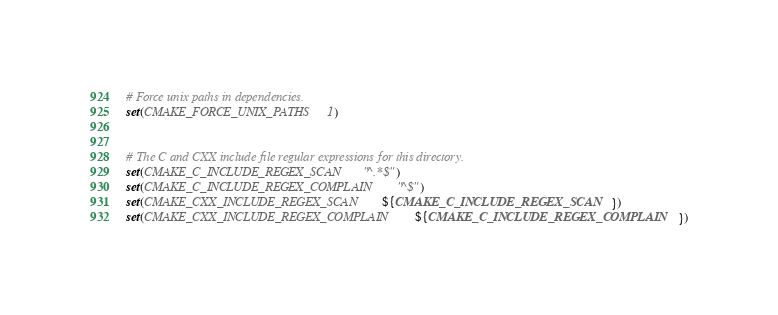Convert code to text. <code><loc_0><loc_0><loc_500><loc_500><_CMake_>
# Force unix paths in dependencies.
set(CMAKE_FORCE_UNIX_PATHS 1)


# The C and CXX include file regular expressions for this directory.
set(CMAKE_C_INCLUDE_REGEX_SCAN "^.*$")
set(CMAKE_C_INCLUDE_REGEX_COMPLAIN "^$")
set(CMAKE_CXX_INCLUDE_REGEX_SCAN ${CMAKE_C_INCLUDE_REGEX_SCAN})
set(CMAKE_CXX_INCLUDE_REGEX_COMPLAIN ${CMAKE_C_INCLUDE_REGEX_COMPLAIN})
</code> 